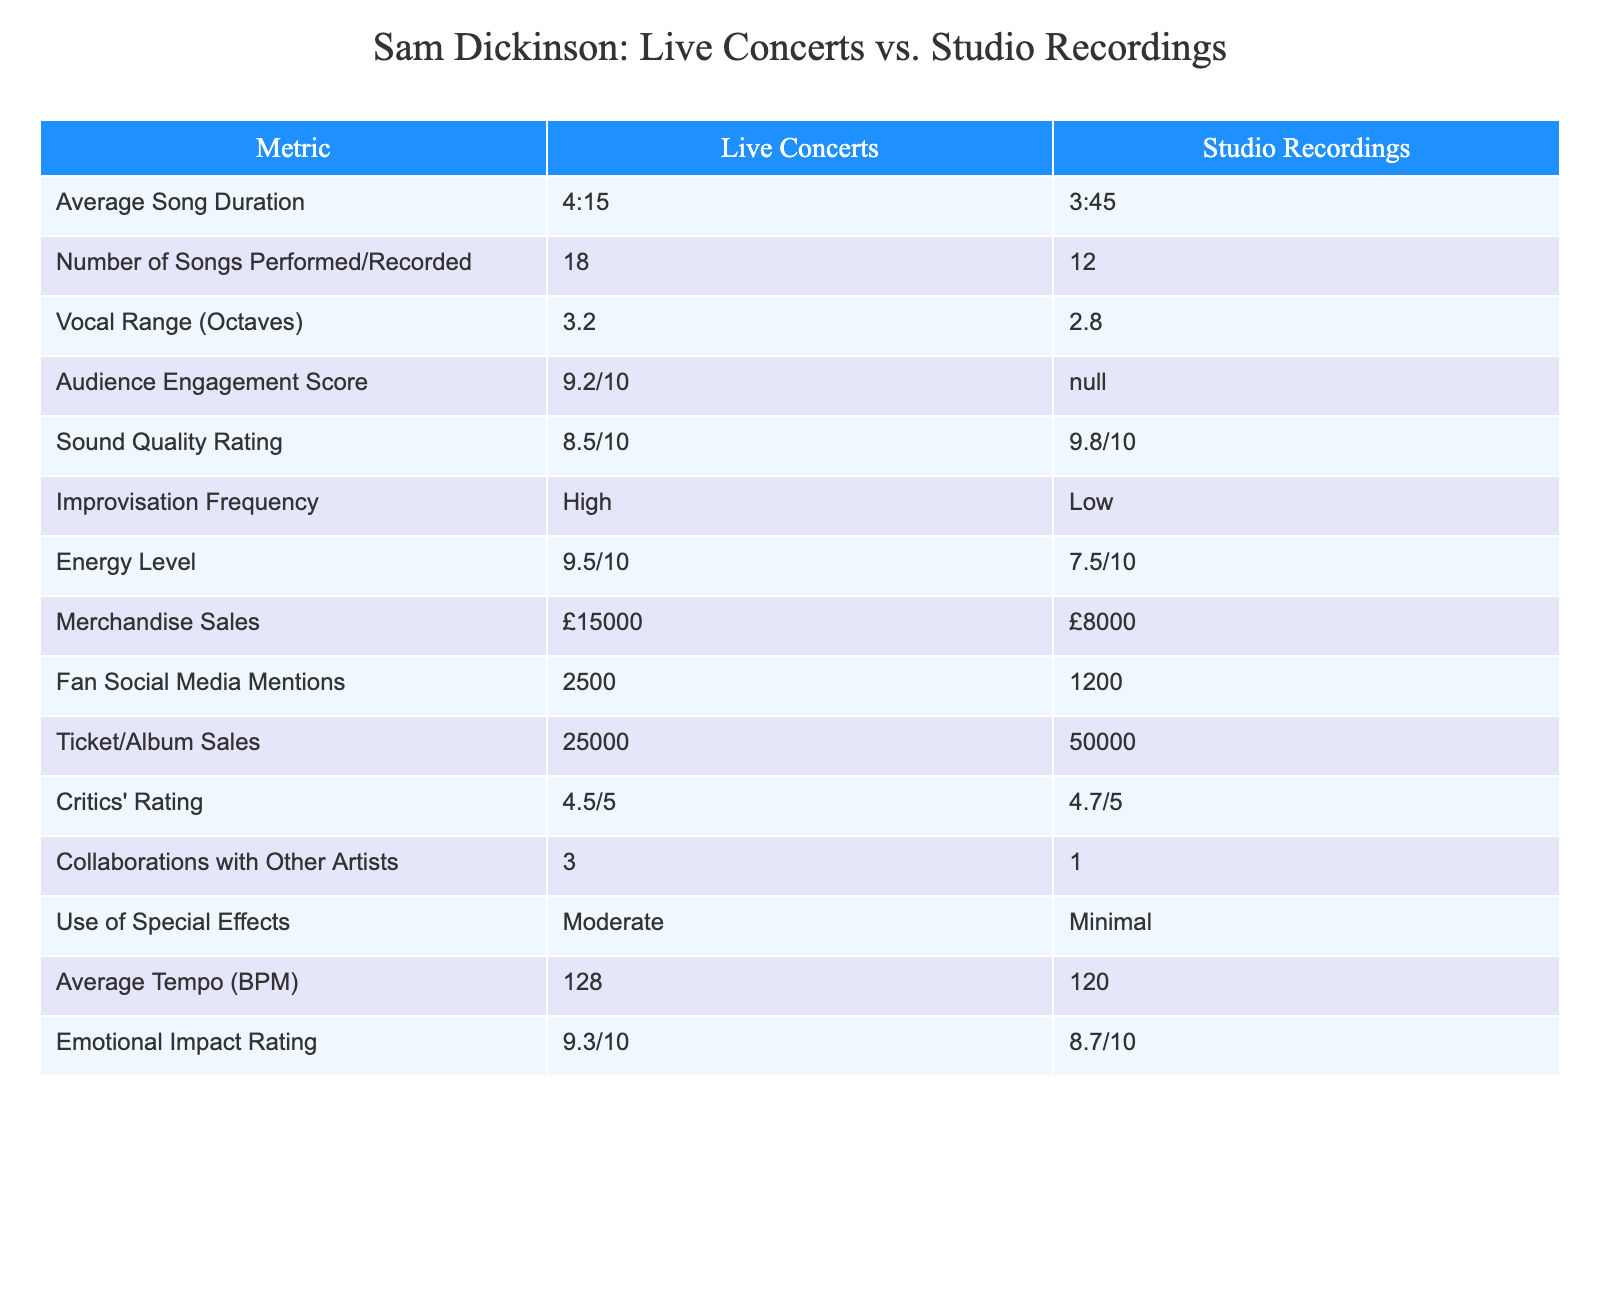What is the Average Song Duration for Live Concerts? The Average Song Duration for Live Concerts is provided in the table as 4:15. This is a direct retrieval question that can be answered directly by looking at the "Average Song Duration" row under "Live Concerts."
Answer: 4:15 What is the Audience Engagement Score for Studio Recordings? The Audience Engagement Score for Studio Recordings is indicated as N/A in the table. This means that there is no data available for this metric in Studio Recordings, which is readily visible in the corresponding cell.
Answer: N/A How many more songs are typically performed in Live Concerts compared to Studio Recordings? Live Concerts have 18 songs while Studio Recordings have 12 songs. To find the difference, we subtract the number of Studio Recording songs from the number of Live Concert songs: 18 - 12 = 6. Therefore, 6 more songs are performed in Live Concerts.
Answer: 6 What is the difference in Vocal Range between Live Concerts and Studio Recordings? The Vocal Range for Live Concerts is 3.2 octaves, and for Studio Recordings, it is 2.8 octaves. To find the difference, we subtract 2.8 from 3.2: 3.2 - 2.8 = 0.4 octaves. Thus, the difference in Vocal Range is 0.4 octaves.
Answer: 0.4 octaves Is the Energy Level higher in Live Concerts than in Studio Recordings? The Energy Level for Live Concerts is rated at 9.5/10 while the Studio Recordings have a rating of 7.5/10. Since 9.5 is greater than 7.5, we can confirm that the Energy Level is indeed higher in Live Concerts.
Answer: Yes How do Merchandise Sales compare between Live Concerts and Studio Recordings? Merchandise Sales for Live Concerts amount to £15,000, while for Studio Recordings, they are £8,000. This comparison shows that Live Concerts have £7,000 more in Merchandise Sales than Studio Recordings, calculated as £15,000 - £8,000 = £7,000.
Answer: £7,000 What is the total of Fan Social Media Mentions for both Live Concerts and Studio Recordings? Fan Social Media Mentions for Live Concerts is 2500, and for Studio Recordings, it is 1200. To find the total, we add these two numbers: 2500 + 1200 = 3700. Therefore, the total Fan Social Media Mentions for both is 3700.
Answer: 3700 Which metric received a higher rating: Sound Quality in Studio Recordings or Critics' Rating for Live Concerts? The Sound Quality Rating for Studio Recordings is 9.8/10, while the Critics' Rating for Live Concerts is 4.5/5. To directly compare these, we first convert the Critics' Rating to a 10-point scale: 4.5 out of 5 is equivalent to 9 out of 10 (4.5 * 2). Since 9.8 is greater than 9, the Sound Quality in Studio Recordings received a higher rating.
Answer: Sound Quality in Studio Recordings What is the ratio of Ticket/Album Sales for Live Concerts to Studio Recordings? Ticket/Album Sales for Live Concerts are 25,000, and for Studio Recordings, they are 50,000. To find the ratio, we divide the Live Concert sales by the Studio Recording sales: 25000 / 50000 = 0.5. Therefore, the ratio of Ticket/Album Sales for Live Concerts to Studio Recordings is 0.5:1.
Answer: 0.5:1 